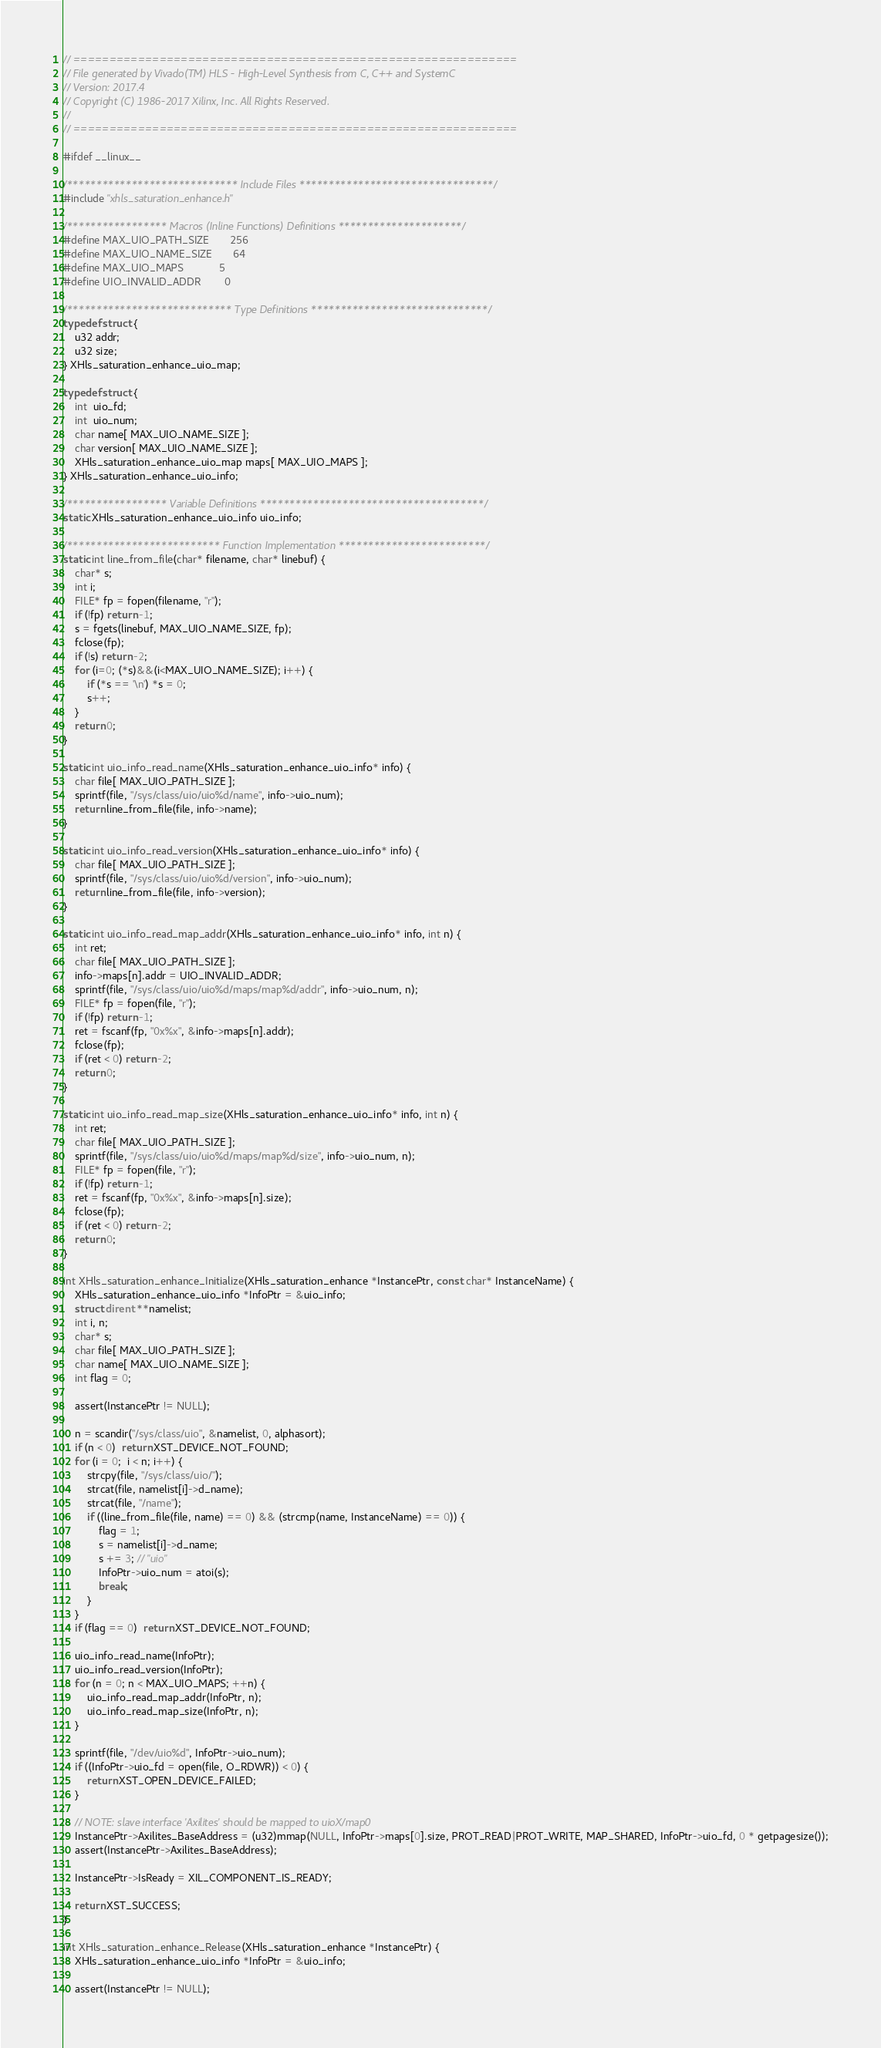<code> <loc_0><loc_0><loc_500><loc_500><_C_>// ==============================================================
// File generated by Vivado(TM) HLS - High-Level Synthesis from C, C++ and SystemC
// Version: 2017.4
// Copyright (C) 1986-2017 Xilinx, Inc. All Rights Reserved.
// 
// ==============================================================

#ifdef __linux__

/***************************** Include Files *********************************/
#include "xhls_saturation_enhance.h"

/***************** Macros (Inline Functions) Definitions *********************/
#define MAX_UIO_PATH_SIZE       256
#define MAX_UIO_NAME_SIZE       64
#define MAX_UIO_MAPS            5
#define UIO_INVALID_ADDR        0

/**************************** Type Definitions ******************************/
typedef struct {
    u32 addr;
    u32 size;
} XHls_saturation_enhance_uio_map;

typedef struct {
    int  uio_fd;
    int  uio_num;
    char name[ MAX_UIO_NAME_SIZE ];
    char version[ MAX_UIO_NAME_SIZE ];
    XHls_saturation_enhance_uio_map maps[ MAX_UIO_MAPS ];
} XHls_saturation_enhance_uio_info;

/***************** Variable Definitions **************************************/
static XHls_saturation_enhance_uio_info uio_info;

/************************** Function Implementation *************************/
static int line_from_file(char* filename, char* linebuf) {
    char* s;
    int i;
    FILE* fp = fopen(filename, "r");
    if (!fp) return -1;
    s = fgets(linebuf, MAX_UIO_NAME_SIZE, fp);
    fclose(fp);
    if (!s) return -2;
    for (i=0; (*s)&&(i<MAX_UIO_NAME_SIZE); i++) {
        if (*s == '\n') *s = 0;
        s++;
    }
    return 0;
}

static int uio_info_read_name(XHls_saturation_enhance_uio_info* info) {
    char file[ MAX_UIO_PATH_SIZE ];
    sprintf(file, "/sys/class/uio/uio%d/name", info->uio_num);
    return line_from_file(file, info->name);
}

static int uio_info_read_version(XHls_saturation_enhance_uio_info* info) {
    char file[ MAX_UIO_PATH_SIZE ];
    sprintf(file, "/sys/class/uio/uio%d/version", info->uio_num);
    return line_from_file(file, info->version);
}

static int uio_info_read_map_addr(XHls_saturation_enhance_uio_info* info, int n) {
    int ret;
    char file[ MAX_UIO_PATH_SIZE ];
    info->maps[n].addr = UIO_INVALID_ADDR;
    sprintf(file, "/sys/class/uio/uio%d/maps/map%d/addr", info->uio_num, n);
    FILE* fp = fopen(file, "r");
    if (!fp) return -1;
    ret = fscanf(fp, "0x%x", &info->maps[n].addr);
    fclose(fp);
    if (ret < 0) return -2;
    return 0;
}

static int uio_info_read_map_size(XHls_saturation_enhance_uio_info* info, int n) {
    int ret;
    char file[ MAX_UIO_PATH_SIZE ];
    sprintf(file, "/sys/class/uio/uio%d/maps/map%d/size", info->uio_num, n);
    FILE* fp = fopen(file, "r");
    if (!fp) return -1;
    ret = fscanf(fp, "0x%x", &info->maps[n].size);
    fclose(fp);
    if (ret < 0) return -2;
    return 0;
}

int XHls_saturation_enhance_Initialize(XHls_saturation_enhance *InstancePtr, const char* InstanceName) {
	XHls_saturation_enhance_uio_info *InfoPtr = &uio_info;
	struct dirent **namelist;
    int i, n;
    char* s;
    char file[ MAX_UIO_PATH_SIZE ];
    char name[ MAX_UIO_NAME_SIZE ];
    int flag = 0;

    assert(InstancePtr != NULL);

    n = scandir("/sys/class/uio", &namelist, 0, alphasort);
    if (n < 0)  return XST_DEVICE_NOT_FOUND;
    for (i = 0;  i < n; i++) {
    	strcpy(file, "/sys/class/uio/");
    	strcat(file, namelist[i]->d_name);
    	strcat(file, "/name");
        if ((line_from_file(file, name) == 0) && (strcmp(name, InstanceName) == 0)) {
            flag = 1;
            s = namelist[i]->d_name;
            s += 3; // "uio"
            InfoPtr->uio_num = atoi(s);
            break;
        }
    }
    if (flag == 0)  return XST_DEVICE_NOT_FOUND;

    uio_info_read_name(InfoPtr);
    uio_info_read_version(InfoPtr);
    for (n = 0; n < MAX_UIO_MAPS; ++n) {
        uio_info_read_map_addr(InfoPtr, n);
        uio_info_read_map_size(InfoPtr, n);
    }

    sprintf(file, "/dev/uio%d", InfoPtr->uio_num);
    if ((InfoPtr->uio_fd = open(file, O_RDWR)) < 0) {
        return XST_OPEN_DEVICE_FAILED;
    }

    // NOTE: slave interface 'Axilites' should be mapped to uioX/map0
    InstancePtr->Axilites_BaseAddress = (u32)mmap(NULL, InfoPtr->maps[0].size, PROT_READ|PROT_WRITE, MAP_SHARED, InfoPtr->uio_fd, 0 * getpagesize());
    assert(InstancePtr->Axilites_BaseAddress);

    InstancePtr->IsReady = XIL_COMPONENT_IS_READY;

    return XST_SUCCESS;
}

int XHls_saturation_enhance_Release(XHls_saturation_enhance *InstancePtr) {
	XHls_saturation_enhance_uio_info *InfoPtr = &uio_info;

    assert(InstancePtr != NULL);</code> 